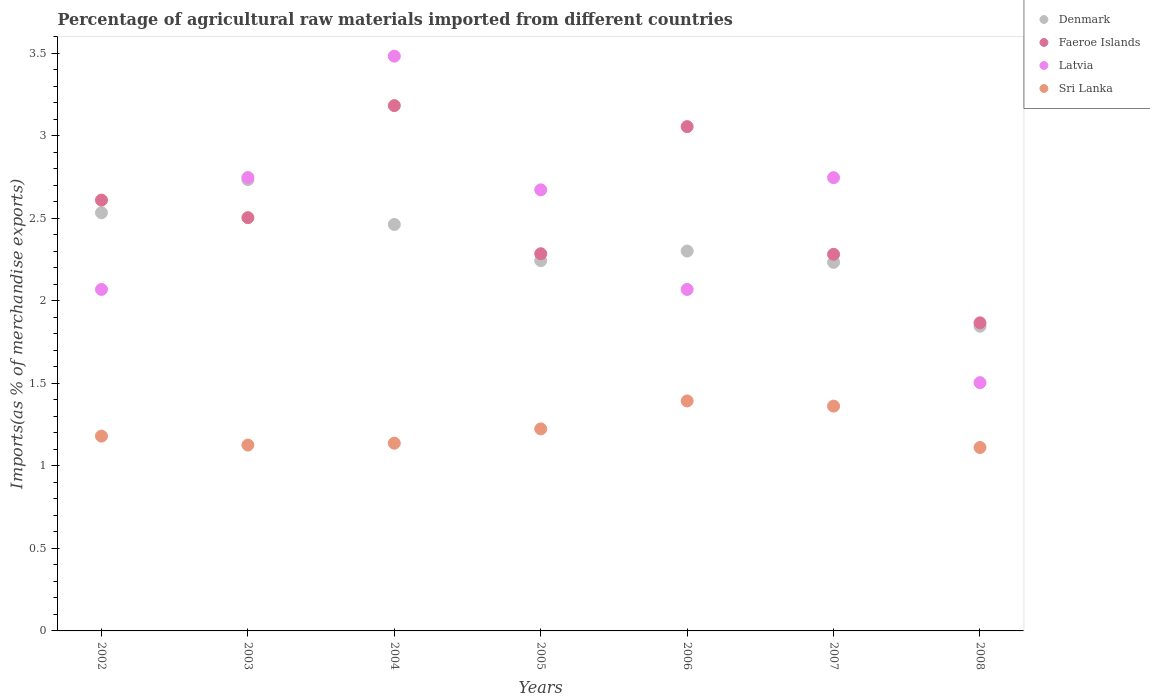Is the number of dotlines equal to the number of legend labels?
Give a very brief answer. Yes. What is the percentage of imports to different countries in Sri Lanka in 2003?
Your response must be concise. 1.13. Across all years, what is the maximum percentage of imports to different countries in Denmark?
Offer a very short reply. 2.73. Across all years, what is the minimum percentage of imports to different countries in Denmark?
Your answer should be very brief. 1.85. In which year was the percentage of imports to different countries in Faeroe Islands minimum?
Offer a terse response. 2008. What is the total percentage of imports to different countries in Latvia in the graph?
Provide a short and direct response. 17.29. What is the difference between the percentage of imports to different countries in Latvia in 2005 and that in 2008?
Your response must be concise. 1.17. What is the difference between the percentage of imports to different countries in Latvia in 2006 and the percentage of imports to different countries in Denmark in 2003?
Your answer should be compact. -0.67. What is the average percentage of imports to different countries in Latvia per year?
Your answer should be compact. 2.47. In the year 2002, what is the difference between the percentage of imports to different countries in Latvia and percentage of imports to different countries in Faeroe Islands?
Your answer should be very brief. -0.54. What is the ratio of the percentage of imports to different countries in Faeroe Islands in 2003 to that in 2005?
Keep it short and to the point. 1.1. Is the difference between the percentage of imports to different countries in Latvia in 2006 and 2007 greater than the difference between the percentage of imports to different countries in Faeroe Islands in 2006 and 2007?
Your answer should be compact. No. What is the difference between the highest and the second highest percentage of imports to different countries in Denmark?
Ensure brevity in your answer.  0.2. What is the difference between the highest and the lowest percentage of imports to different countries in Sri Lanka?
Provide a short and direct response. 0.28. Is it the case that in every year, the sum of the percentage of imports to different countries in Faeroe Islands and percentage of imports to different countries in Sri Lanka  is greater than the sum of percentage of imports to different countries in Latvia and percentage of imports to different countries in Denmark?
Provide a succinct answer. No. Is it the case that in every year, the sum of the percentage of imports to different countries in Sri Lanka and percentage of imports to different countries in Latvia  is greater than the percentage of imports to different countries in Denmark?
Your answer should be very brief. Yes. How many dotlines are there?
Your response must be concise. 4. How many years are there in the graph?
Your answer should be compact. 7. Are the values on the major ticks of Y-axis written in scientific E-notation?
Provide a short and direct response. No. What is the title of the graph?
Offer a terse response. Percentage of agricultural raw materials imported from different countries. Does "Austria" appear as one of the legend labels in the graph?
Make the answer very short. No. What is the label or title of the X-axis?
Offer a terse response. Years. What is the label or title of the Y-axis?
Offer a terse response. Imports(as % of merchandise exports). What is the Imports(as % of merchandise exports) in Denmark in 2002?
Provide a succinct answer. 2.53. What is the Imports(as % of merchandise exports) of Faeroe Islands in 2002?
Your answer should be very brief. 2.61. What is the Imports(as % of merchandise exports) in Latvia in 2002?
Your answer should be compact. 2.07. What is the Imports(as % of merchandise exports) in Sri Lanka in 2002?
Your answer should be very brief. 1.18. What is the Imports(as % of merchandise exports) in Denmark in 2003?
Provide a succinct answer. 2.73. What is the Imports(as % of merchandise exports) in Faeroe Islands in 2003?
Provide a succinct answer. 2.5. What is the Imports(as % of merchandise exports) of Latvia in 2003?
Your answer should be compact. 2.75. What is the Imports(as % of merchandise exports) of Sri Lanka in 2003?
Provide a succinct answer. 1.13. What is the Imports(as % of merchandise exports) in Denmark in 2004?
Your answer should be very brief. 2.46. What is the Imports(as % of merchandise exports) of Faeroe Islands in 2004?
Give a very brief answer. 3.18. What is the Imports(as % of merchandise exports) in Latvia in 2004?
Ensure brevity in your answer.  3.48. What is the Imports(as % of merchandise exports) of Sri Lanka in 2004?
Make the answer very short. 1.14. What is the Imports(as % of merchandise exports) in Denmark in 2005?
Ensure brevity in your answer.  2.24. What is the Imports(as % of merchandise exports) in Faeroe Islands in 2005?
Offer a terse response. 2.29. What is the Imports(as % of merchandise exports) of Latvia in 2005?
Your response must be concise. 2.67. What is the Imports(as % of merchandise exports) in Sri Lanka in 2005?
Offer a very short reply. 1.22. What is the Imports(as % of merchandise exports) in Denmark in 2006?
Provide a succinct answer. 2.3. What is the Imports(as % of merchandise exports) of Faeroe Islands in 2006?
Provide a succinct answer. 3.06. What is the Imports(as % of merchandise exports) of Latvia in 2006?
Ensure brevity in your answer.  2.07. What is the Imports(as % of merchandise exports) of Sri Lanka in 2006?
Your answer should be compact. 1.39. What is the Imports(as % of merchandise exports) of Denmark in 2007?
Make the answer very short. 2.23. What is the Imports(as % of merchandise exports) in Faeroe Islands in 2007?
Provide a short and direct response. 2.28. What is the Imports(as % of merchandise exports) of Latvia in 2007?
Make the answer very short. 2.75. What is the Imports(as % of merchandise exports) in Sri Lanka in 2007?
Provide a succinct answer. 1.36. What is the Imports(as % of merchandise exports) in Denmark in 2008?
Your answer should be very brief. 1.85. What is the Imports(as % of merchandise exports) of Faeroe Islands in 2008?
Make the answer very short. 1.87. What is the Imports(as % of merchandise exports) of Latvia in 2008?
Provide a succinct answer. 1.5. What is the Imports(as % of merchandise exports) of Sri Lanka in 2008?
Provide a succinct answer. 1.11. Across all years, what is the maximum Imports(as % of merchandise exports) of Denmark?
Offer a very short reply. 2.73. Across all years, what is the maximum Imports(as % of merchandise exports) in Faeroe Islands?
Your answer should be compact. 3.18. Across all years, what is the maximum Imports(as % of merchandise exports) of Latvia?
Ensure brevity in your answer.  3.48. Across all years, what is the maximum Imports(as % of merchandise exports) of Sri Lanka?
Give a very brief answer. 1.39. Across all years, what is the minimum Imports(as % of merchandise exports) in Denmark?
Offer a terse response. 1.85. Across all years, what is the minimum Imports(as % of merchandise exports) in Faeroe Islands?
Offer a terse response. 1.87. Across all years, what is the minimum Imports(as % of merchandise exports) in Latvia?
Offer a terse response. 1.5. Across all years, what is the minimum Imports(as % of merchandise exports) in Sri Lanka?
Make the answer very short. 1.11. What is the total Imports(as % of merchandise exports) of Denmark in the graph?
Make the answer very short. 16.35. What is the total Imports(as % of merchandise exports) in Faeroe Islands in the graph?
Give a very brief answer. 17.79. What is the total Imports(as % of merchandise exports) in Latvia in the graph?
Provide a succinct answer. 17.29. What is the total Imports(as % of merchandise exports) of Sri Lanka in the graph?
Give a very brief answer. 8.54. What is the difference between the Imports(as % of merchandise exports) of Denmark in 2002 and that in 2003?
Offer a terse response. -0.2. What is the difference between the Imports(as % of merchandise exports) in Faeroe Islands in 2002 and that in 2003?
Make the answer very short. 0.11. What is the difference between the Imports(as % of merchandise exports) in Latvia in 2002 and that in 2003?
Your answer should be very brief. -0.68. What is the difference between the Imports(as % of merchandise exports) in Sri Lanka in 2002 and that in 2003?
Keep it short and to the point. 0.05. What is the difference between the Imports(as % of merchandise exports) of Denmark in 2002 and that in 2004?
Give a very brief answer. 0.07. What is the difference between the Imports(as % of merchandise exports) in Faeroe Islands in 2002 and that in 2004?
Ensure brevity in your answer.  -0.57. What is the difference between the Imports(as % of merchandise exports) in Latvia in 2002 and that in 2004?
Your response must be concise. -1.41. What is the difference between the Imports(as % of merchandise exports) in Sri Lanka in 2002 and that in 2004?
Your response must be concise. 0.04. What is the difference between the Imports(as % of merchandise exports) in Denmark in 2002 and that in 2005?
Give a very brief answer. 0.29. What is the difference between the Imports(as % of merchandise exports) in Faeroe Islands in 2002 and that in 2005?
Offer a very short reply. 0.32. What is the difference between the Imports(as % of merchandise exports) of Latvia in 2002 and that in 2005?
Ensure brevity in your answer.  -0.6. What is the difference between the Imports(as % of merchandise exports) in Sri Lanka in 2002 and that in 2005?
Ensure brevity in your answer.  -0.04. What is the difference between the Imports(as % of merchandise exports) in Denmark in 2002 and that in 2006?
Offer a very short reply. 0.23. What is the difference between the Imports(as % of merchandise exports) of Faeroe Islands in 2002 and that in 2006?
Your answer should be very brief. -0.45. What is the difference between the Imports(as % of merchandise exports) in Latvia in 2002 and that in 2006?
Provide a succinct answer. -0. What is the difference between the Imports(as % of merchandise exports) in Sri Lanka in 2002 and that in 2006?
Your answer should be very brief. -0.21. What is the difference between the Imports(as % of merchandise exports) in Denmark in 2002 and that in 2007?
Offer a terse response. 0.3. What is the difference between the Imports(as % of merchandise exports) in Faeroe Islands in 2002 and that in 2007?
Give a very brief answer. 0.33. What is the difference between the Imports(as % of merchandise exports) in Latvia in 2002 and that in 2007?
Your answer should be very brief. -0.68. What is the difference between the Imports(as % of merchandise exports) in Sri Lanka in 2002 and that in 2007?
Ensure brevity in your answer.  -0.18. What is the difference between the Imports(as % of merchandise exports) in Denmark in 2002 and that in 2008?
Make the answer very short. 0.69. What is the difference between the Imports(as % of merchandise exports) in Faeroe Islands in 2002 and that in 2008?
Ensure brevity in your answer.  0.74. What is the difference between the Imports(as % of merchandise exports) of Latvia in 2002 and that in 2008?
Your answer should be very brief. 0.56. What is the difference between the Imports(as % of merchandise exports) of Sri Lanka in 2002 and that in 2008?
Provide a succinct answer. 0.07. What is the difference between the Imports(as % of merchandise exports) of Denmark in 2003 and that in 2004?
Make the answer very short. 0.27. What is the difference between the Imports(as % of merchandise exports) of Faeroe Islands in 2003 and that in 2004?
Ensure brevity in your answer.  -0.68. What is the difference between the Imports(as % of merchandise exports) of Latvia in 2003 and that in 2004?
Your response must be concise. -0.74. What is the difference between the Imports(as % of merchandise exports) in Sri Lanka in 2003 and that in 2004?
Offer a terse response. -0.01. What is the difference between the Imports(as % of merchandise exports) in Denmark in 2003 and that in 2005?
Give a very brief answer. 0.49. What is the difference between the Imports(as % of merchandise exports) of Faeroe Islands in 2003 and that in 2005?
Your response must be concise. 0.22. What is the difference between the Imports(as % of merchandise exports) of Latvia in 2003 and that in 2005?
Ensure brevity in your answer.  0.07. What is the difference between the Imports(as % of merchandise exports) in Sri Lanka in 2003 and that in 2005?
Ensure brevity in your answer.  -0.1. What is the difference between the Imports(as % of merchandise exports) in Denmark in 2003 and that in 2006?
Your answer should be very brief. 0.43. What is the difference between the Imports(as % of merchandise exports) in Faeroe Islands in 2003 and that in 2006?
Provide a short and direct response. -0.55. What is the difference between the Imports(as % of merchandise exports) in Latvia in 2003 and that in 2006?
Make the answer very short. 0.68. What is the difference between the Imports(as % of merchandise exports) in Sri Lanka in 2003 and that in 2006?
Make the answer very short. -0.27. What is the difference between the Imports(as % of merchandise exports) in Denmark in 2003 and that in 2007?
Offer a terse response. 0.5. What is the difference between the Imports(as % of merchandise exports) in Faeroe Islands in 2003 and that in 2007?
Your response must be concise. 0.22. What is the difference between the Imports(as % of merchandise exports) of Latvia in 2003 and that in 2007?
Your answer should be very brief. 0. What is the difference between the Imports(as % of merchandise exports) of Sri Lanka in 2003 and that in 2007?
Provide a succinct answer. -0.24. What is the difference between the Imports(as % of merchandise exports) in Denmark in 2003 and that in 2008?
Provide a short and direct response. 0.89. What is the difference between the Imports(as % of merchandise exports) of Faeroe Islands in 2003 and that in 2008?
Make the answer very short. 0.64. What is the difference between the Imports(as % of merchandise exports) of Latvia in 2003 and that in 2008?
Your response must be concise. 1.24. What is the difference between the Imports(as % of merchandise exports) of Sri Lanka in 2003 and that in 2008?
Provide a short and direct response. 0.01. What is the difference between the Imports(as % of merchandise exports) of Denmark in 2004 and that in 2005?
Offer a terse response. 0.22. What is the difference between the Imports(as % of merchandise exports) of Faeroe Islands in 2004 and that in 2005?
Offer a very short reply. 0.9. What is the difference between the Imports(as % of merchandise exports) of Latvia in 2004 and that in 2005?
Make the answer very short. 0.81. What is the difference between the Imports(as % of merchandise exports) in Sri Lanka in 2004 and that in 2005?
Offer a very short reply. -0.09. What is the difference between the Imports(as % of merchandise exports) in Denmark in 2004 and that in 2006?
Ensure brevity in your answer.  0.16. What is the difference between the Imports(as % of merchandise exports) in Faeroe Islands in 2004 and that in 2006?
Provide a succinct answer. 0.13. What is the difference between the Imports(as % of merchandise exports) in Latvia in 2004 and that in 2006?
Provide a succinct answer. 1.41. What is the difference between the Imports(as % of merchandise exports) of Sri Lanka in 2004 and that in 2006?
Offer a very short reply. -0.26. What is the difference between the Imports(as % of merchandise exports) in Denmark in 2004 and that in 2007?
Your response must be concise. 0.23. What is the difference between the Imports(as % of merchandise exports) of Faeroe Islands in 2004 and that in 2007?
Provide a short and direct response. 0.9. What is the difference between the Imports(as % of merchandise exports) of Latvia in 2004 and that in 2007?
Ensure brevity in your answer.  0.74. What is the difference between the Imports(as % of merchandise exports) in Sri Lanka in 2004 and that in 2007?
Offer a terse response. -0.22. What is the difference between the Imports(as % of merchandise exports) of Denmark in 2004 and that in 2008?
Ensure brevity in your answer.  0.62. What is the difference between the Imports(as % of merchandise exports) in Faeroe Islands in 2004 and that in 2008?
Provide a short and direct response. 1.32. What is the difference between the Imports(as % of merchandise exports) in Latvia in 2004 and that in 2008?
Provide a succinct answer. 1.98. What is the difference between the Imports(as % of merchandise exports) of Sri Lanka in 2004 and that in 2008?
Give a very brief answer. 0.03. What is the difference between the Imports(as % of merchandise exports) of Denmark in 2005 and that in 2006?
Provide a short and direct response. -0.06. What is the difference between the Imports(as % of merchandise exports) in Faeroe Islands in 2005 and that in 2006?
Provide a succinct answer. -0.77. What is the difference between the Imports(as % of merchandise exports) of Latvia in 2005 and that in 2006?
Provide a succinct answer. 0.6. What is the difference between the Imports(as % of merchandise exports) in Sri Lanka in 2005 and that in 2006?
Your response must be concise. -0.17. What is the difference between the Imports(as % of merchandise exports) of Denmark in 2005 and that in 2007?
Keep it short and to the point. 0.01. What is the difference between the Imports(as % of merchandise exports) in Faeroe Islands in 2005 and that in 2007?
Provide a short and direct response. 0. What is the difference between the Imports(as % of merchandise exports) of Latvia in 2005 and that in 2007?
Give a very brief answer. -0.07. What is the difference between the Imports(as % of merchandise exports) in Sri Lanka in 2005 and that in 2007?
Provide a short and direct response. -0.14. What is the difference between the Imports(as % of merchandise exports) of Denmark in 2005 and that in 2008?
Keep it short and to the point. 0.4. What is the difference between the Imports(as % of merchandise exports) of Faeroe Islands in 2005 and that in 2008?
Give a very brief answer. 0.42. What is the difference between the Imports(as % of merchandise exports) of Latvia in 2005 and that in 2008?
Offer a terse response. 1.17. What is the difference between the Imports(as % of merchandise exports) of Sri Lanka in 2005 and that in 2008?
Your response must be concise. 0.11. What is the difference between the Imports(as % of merchandise exports) in Denmark in 2006 and that in 2007?
Ensure brevity in your answer.  0.07. What is the difference between the Imports(as % of merchandise exports) of Faeroe Islands in 2006 and that in 2007?
Keep it short and to the point. 0.77. What is the difference between the Imports(as % of merchandise exports) of Latvia in 2006 and that in 2007?
Keep it short and to the point. -0.68. What is the difference between the Imports(as % of merchandise exports) of Sri Lanka in 2006 and that in 2007?
Your response must be concise. 0.03. What is the difference between the Imports(as % of merchandise exports) in Denmark in 2006 and that in 2008?
Your response must be concise. 0.46. What is the difference between the Imports(as % of merchandise exports) in Faeroe Islands in 2006 and that in 2008?
Give a very brief answer. 1.19. What is the difference between the Imports(as % of merchandise exports) of Latvia in 2006 and that in 2008?
Ensure brevity in your answer.  0.56. What is the difference between the Imports(as % of merchandise exports) of Sri Lanka in 2006 and that in 2008?
Your response must be concise. 0.28. What is the difference between the Imports(as % of merchandise exports) of Denmark in 2007 and that in 2008?
Your answer should be compact. 0.39. What is the difference between the Imports(as % of merchandise exports) of Faeroe Islands in 2007 and that in 2008?
Your answer should be very brief. 0.42. What is the difference between the Imports(as % of merchandise exports) of Latvia in 2007 and that in 2008?
Your answer should be compact. 1.24. What is the difference between the Imports(as % of merchandise exports) in Sri Lanka in 2007 and that in 2008?
Provide a short and direct response. 0.25. What is the difference between the Imports(as % of merchandise exports) of Denmark in 2002 and the Imports(as % of merchandise exports) of Faeroe Islands in 2003?
Your response must be concise. 0.03. What is the difference between the Imports(as % of merchandise exports) of Denmark in 2002 and the Imports(as % of merchandise exports) of Latvia in 2003?
Offer a terse response. -0.21. What is the difference between the Imports(as % of merchandise exports) in Denmark in 2002 and the Imports(as % of merchandise exports) in Sri Lanka in 2003?
Your answer should be very brief. 1.41. What is the difference between the Imports(as % of merchandise exports) of Faeroe Islands in 2002 and the Imports(as % of merchandise exports) of Latvia in 2003?
Keep it short and to the point. -0.14. What is the difference between the Imports(as % of merchandise exports) of Faeroe Islands in 2002 and the Imports(as % of merchandise exports) of Sri Lanka in 2003?
Offer a very short reply. 1.48. What is the difference between the Imports(as % of merchandise exports) in Latvia in 2002 and the Imports(as % of merchandise exports) in Sri Lanka in 2003?
Provide a short and direct response. 0.94. What is the difference between the Imports(as % of merchandise exports) of Denmark in 2002 and the Imports(as % of merchandise exports) of Faeroe Islands in 2004?
Offer a terse response. -0.65. What is the difference between the Imports(as % of merchandise exports) of Denmark in 2002 and the Imports(as % of merchandise exports) of Latvia in 2004?
Your response must be concise. -0.95. What is the difference between the Imports(as % of merchandise exports) of Denmark in 2002 and the Imports(as % of merchandise exports) of Sri Lanka in 2004?
Make the answer very short. 1.4. What is the difference between the Imports(as % of merchandise exports) of Faeroe Islands in 2002 and the Imports(as % of merchandise exports) of Latvia in 2004?
Offer a very short reply. -0.87. What is the difference between the Imports(as % of merchandise exports) in Faeroe Islands in 2002 and the Imports(as % of merchandise exports) in Sri Lanka in 2004?
Give a very brief answer. 1.47. What is the difference between the Imports(as % of merchandise exports) in Latvia in 2002 and the Imports(as % of merchandise exports) in Sri Lanka in 2004?
Your answer should be very brief. 0.93. What is the difference between the Imports(as % of merchandise exports) in Denmark in 2002 and the Imports(as % of merchandise exports) in Faeroe Islands in 2005?
Provide a succinct answer. 0.25. What is the difference between the Imports(as % of merchandise exports) in Denmark in 2002 and the Imports(as % of merchandise exports) in Latvia in 2005?
Provide a short and direct response. -0.14. What is the difference between the Imports(as % of merchandise exports) of Denmark in 2002 and the Imports(as % of merchandise exports) of Sri Lanka in 2005?
Provide a succinct answer. 1.31. What is the difference between the Imports(as % of merchandise exports) of Faeroe Islands in 2002 and the Imports(as % of merchandise exports) of Latvia in 2005?
Make the answer very short. -0.06. What is the difference between the Imports(as % of merchandise exports) in Faeroe Islands in 2002 and the Imports(as % of merchandise exports) in Sri Lanka in 2005?
Ensure brevity in your answer.  1.39. What is the difference between the Imports(as % of merchandise exports) of Latvia in 2002 and the Imports(as % of merchandise exports) of Sri Lanka in 2005?
Provide a short and direct response. 0.84. What is the difference between the Imports(as % of merchandise exports) in Denmark in 2002 and the Imports(as % of merchandise exports) in Faeroe Islands in 2006?
Your answer should be compact. -0.52. What is the difference between the Imports(as % of merchandise exports) of Denmark in 2002 and the Imports(as % of merchandise exports) of Latvia in 2006?
Make the answer very short. 0.46. What is the difference between the Imports(as % of merchandise exports) in Denmark in 2002 and the Imports(as % of merchandise exports) in Sri Lanka in 2006?
Offer a terse response. 1.14. What is the difference between the Imports(as % of merchandise exports) of Faeroe Islands in 2002 and the Imports(as % of merchandise exports) of Latvia in 2006?
Make the answer very short. 0.54. What is the difference between the Imports(as % of merchandise exports) in Faeroe Islands in 2002 and the Imports(as % of merchandise exports) in Sri Lanka in 2006?
Give a very brief answer. 1.22. What is the difference between the Imports(as % of merchandise exports) in Latvia in 2002 and the Imports(as % of merchandise exports) in Sri Lanka in 2006?
Provide a short and direct response. 0.68. What is the difference between the Imports(as % of merchandise exports) of Denmark in 2002 and the Imports(as % of merchandise exports) of Faeroe Islands in 2007?
Offer a terse response. 0.25. What is the difference between the Imports(as % of merchandise exports) of Denmark in 2002 and the Imports(as % of merchandise exports) of Latvia in 2007?
Your response must be concise. -0.21. What is the difference between the Imports(as % of merchandise exports) in Denmark in 2002 and the Imports(as % of merchandise exports) in Sri Lanka in 2007?
Keep it short and to the point. 1.17. What is the difference between the Imports(as % of merchandise exports) of Faeroe Islands in 2002 and the Imports(as % of merchandise exports) of Latvia in 2007?
Your answer should be very brief. -0.14. What is the difference between the Imports(as % of merchandise exports) of Faeroe Islands in 2002 and the Imports(as % of merchandise exports) of Sri Lanka in 2007?
Provide a succinct answer. 1.25. What is the difference between the Imports(as % of merchandise exports) in Latvia in 2002 and the Imports(as % of merchandise exports) in Sri Lanka in 2007?
Offer a very short reply. 0.71. What is the difference between the Imports(as % of merchandise exports) in Denmark in 2002 and the Imports(as % of merchandise exports) in Faeroe Islands in 2008?
Provide a short and direct response. 0.67. What is the difference between the Imports(as % of merchandise exports) of Denmark in 2002 and the Imports(as % of merchandise exports) of Latvia in 2008?
Your answer should be compact. 1.03. What is the difference between the Imports(as % of merchandise exports) of Denmark in 2002 and the Imports(as % of merchandise exports) of Sri Lanka in 2008?
Your response must be concise. 1.42. What is the difference between the Imports(as % of merchandise exports) in Faeroe Islands in 2002 and the Imports(as % of merchandise exports) in Latvia in 2008?
Make the answer very short. 1.11. What is the difference between the Imports(as % of merchandise exports) of Faeroe Islands in 2002 and the Imports(as % of merchandise exports) of Sri Lanka in 2008?
Ensure brevity in your answer.  1.5. What is the difference between the Imports(as % of merchandise exports) in Latvia in 2002 and the Imports(as % of merchandise exports) in Sri Lanka in 2008?
Offer a terse response. 0.96. What is the difference between the Imports(as % of merchandise exports) of Denmark in 2003 and the Imports(as % of merchandise exports) of Faeroe Islands in 2004?
Your answer should be compact. -0.45. What is the difference between the Imports(as % of merchandise exports) in Denmark in 2003 and the Imports(as % of merchandise exports) in Latvia in 2004?
Provide a succinct answer. -0.75. What is the difference between the Imports(as % of merchandise exports) in Denmark in 2003 and the Imports(as % of merchandise exports) in Sri Lanka in 2004?
Give a very brief answer. 1.6. What is the difference between the Imports(as % of merchandise exports) in Faeroe Islands in 2003 and the Imports(as % of merchandise exports) in Latvia in 2004?
Keep it short and to the point. -0.98. What is the difference between the Imports(as % of merchandise exports) of Faeroe Islands in 2003 and the Imports(as % of merchandise exports) of Sri Lanka in 2004?
Give a very brief answer. 1.37. What is the difference between the Imports(as % of merchandise exports) in Latvia in 2003 and the Imports(as % of merchandise exports) in Sri Lanka in 2004?
Provide a short and direct response. 1.61. What is the difference between the Imports(as % of merchandise exports) in Denmark in 2003 and the Imports(as % of merchandise exports) in Faeroe Islands in 2005?
Ensure brevity in your answer.  0.45. What is the difference between the Imports(as % of merchandise exports) in Denmark in 2003 and the Imports(as % of merchandise exports) in Latvia in 2005?
Give a very brief answer. 0.06. What is the difference between the Imports(as % of merchandise exports) in Denmark in 2003 and the Imports(as % of merchandise exports) in Sri Lanka in 2005?
Offer a terse response. 1.51. What is the difference between the Imports(as % of merchandise exports) in Faeroe Islands in 2003 and the Imports(as % of merchandise exports) in Latvia in 2005?
Your response must be concise. -0.17. What is the difference between the Imports(as % of merchandise exports) of Faeroe Islands in 2003 and the Imports(as % of merchandise exports) of Sri Lanka in 2005?
Offer a very short reply. 1.28. What is the difference between the Imports(as % of merchandise exports) of Latvia in 2003 and the Imports(as % of merchandise exports) of Sri Lanka in 2005?
Provide a short and direct response. 1.52. What is the difference between the Imports(as % of merchandise exports) in Denmark in 2003 and the Imports(as % of merchandise exports) in Faeroe Islands in 2006?
Offer a terse response. -0.32. What is the difference between the Imports(as % of merchandise exports) in Denmark in 2003 and the Imports(as % of merchandise exports) in Latvia in 2006?
Offer a terse response. 0.67. What is the difference between the Imports(as % of merchandise exports) in Denmark in 2003 and the Imports(as % of merchandise exports) in Sri Lanka in 2006?
Provide a succinct answer. 1.34. What is the difference between the Imports(as % of merchandise exports) in Faeroe Islands in 2003 and the Imports(as % of merchandise exports) in Latvia in 2006?
Your response must be concise. 0.43. What is the difference between the Imports(as % of merchandise exports) of Faeroe Islands in 2003 and the Imports(as % of merchandise exports) of Sri Lanka in 2006?
Keep it short and to the point. 1.11. What is the difference between the Imports(as % of merchandise exports) in Latvia in 2003 and the Imports(as % of merchandise exports) in Sri Lanka in 2006?
Your response must be concise. 1.35. What is the difference between the Imports(as % of merchandise exports) in Denmark in 2003 and the Imports(as % of merchandise exports) in Faeroe Islands in 2007?
Offer a very short reply. 0.45. What is the difference between the Imports(as % of merchandise exports) of Denmark in 2003 and the Imports(as % of merchandise exports) of Latvia in 2007?
Ensure brevity in your answer.  -0.01. What is the difference between the Imports(as % of merchandise exports) in Denmark in 2003 and the Imports(as % of merchandise exports) in Sri Lanka in 2007?
Provide a succinct answer. 1.37. What is the difference between the Imports(as % of merchandise exports) of Faeroe Islands in 2003 and the Imports(as % of merchandise exports) of Latvia in 2007?
Your answer should be very brief. -0.24. What is the difference between the Imports(as % of merchandise exports) of Faeroe Islands in 2003 and the Imports(as % of merchandise exports) of Sri Lanka in 2007?
Your answer should be compact. 1.14. What is the difference between the Imports(as % of merchandise exports) of Latvia in 2003 and the Imports(as % of merchandise exports) of Sri Lanka in 2007?
Offer a very short reply. 1.38. What is the difference between the Imports(as % of merchandise exports) of Denmark in 2003 and the Imports(as % of merchandise exports) of Faeroe Islands in 2008?
Your answer should be very brief. 0.87. What is the difference between the Imports(as % of merchandise exports) of Denmark in 2003 and the Imports(as % of merchandise exports) of Latvia in 2008?
Give a very brief answer. 1.23. What is the difference between the Imports(as % of merchandise exports) in Denmark in 2003 and the Imports(as % of merchandise exports) in Sri Lanka in 2008?
Offer a terse response. 1.62. What is the difference between the Imports(as % of merchandise exports) in Faeroe Islands in 2003 and the Imports(as % of merchandise exports) in Latvia in 2008?
Offer a very short reply. 1. What is the difference between the Imports(as % of merchandise exports) of Faeroe Islands in 2003 and the Imports(as % of merchandise exports) of Sri Lanka in 2008?
Provide a succinct answer. 1.39. What is the difference between the Imports(as % of merchandise exports) in Latvia in 2003 and the Imports(as % of merchandise exports) in Sri Lanka in 2008?
Your answer should be very brief. 1.64. What is the difference between the Imports(as % of merchandise exports) of Denmark in 2004 and the Imports(as % of merchandise exports) of Faeroe Islands in 2005?
Provide a short and direct response. 0.18. What is the difference between the Imports(as % of merchandise exports) of Denmark in 2004 and the Imports(as % of merchandise exports) of Latvia in 2005?
Your response must be concise. -0.21. What is the difference between the Imports(as % of merchandise exports) of Denmark in 2004 and the Imports(as % of merchandise exports) of Sri Lanka in 2005?
Keep it short and to the point. 1.24. What is the difference between the Imports(as % of merchandise exports) in Faeroe Islands in 2004 and the Imports(as % of merchandise exports) in Latvia in 2005?
Ensure brevity in your answer.  0.51. What is the difference between the Imports(as % of merchandise exports) in Faeroe Islands in 2004 and the Imports(as % of merchandise exports) in Sri Lanka in 2005?
Make the answer very short. 1.96. What is the difference between the Imports(as % of merchandise exports) in Latvia in 2004 and the Imports(as % of merchandise exports) in Sri Lanka in 2005?
Give a very brief answer. 2.26. What is the difference between the Imports(as % of merchandise exports) of Denmark in 2004 and the Imports(as % of merchandise exports) of Faeroe Islands in 2006?
Ensure brevity in your answer.  -0.59. What is the difference between the Imports(as % of merchandise exports) in Denmark in 2004 and the Imports(as % of merchandise exports) in Latvia in 2006?
Provide a succinct answer. 0.39. What is the difference between the Imports(as % of merchandise exports) in Denmark in 2004 and the Imports(as % of merchandise exports) in Sri Lanka in 2006?
Give a very brief answer. 1.07. What is the difference between the Imports(as % of merchandise exports) in Faeroe Islands in 2004 and the Imports(as % of merchandise exports) in Latvia in 2006?
Offer a terse response. 1.11. What is the difference between the Imports(as % of merchandise exports) of Faeroe Islands in 2004 and the Imports(as % of merchandise exports) of Sri Lanka in 2006?
Give a very brief answer. 1.79. What is the difference between the Imports(as % of merchandise exports) in Latvia in 2004 and the Imports(as % of merchandise exports) in Sri Lanka in 2006?
Your answer should be compact. 2.09. What is the difference between the Imports(as % of merchandise exports) in Denmark in 2004 and the Imports(as % of merchandise exports) in Faeroe Islands in 2007?
Provide a succinct answer. 0.18. What is the difference between the Imports(as % of merchandise exports) of Denmark in 2004 and the Imports(as % of merchandise exports) of Latvia in 2007?
Your response must be concise. -0.28. What is the difference between the Imports(as % of merchandise exports) in Denmark in 2004 and the Imports(as % of merchandise exports) in Sri Lanka in 2007?
Make the answer very short. 1.1. What is the difference between the Imports(as % of merchandise exports) of Faeroe Islands in 2004 and the Imports(as % of merchandise exports) of Latvia in 2007?
Provide a succinct answer. 0.44. What is the difference between the Imports(as % of merchandise exports) of Faeroe Islands in 2004 and the Imports(as % of merchandise exports) of Sri Lanka in 2007?
Offer a very short reply. 1.82. What is the difference between the Imports(as % of merchandise exports) in Latvia in 2004 and the Imports(as % of merchandise exports) in Sri Lanka in 2007?
Your response must be concise. 2.12. What is the difference between the Imports(as % of merchandise exports) of Denmark in 2004 and the Imports(as % of merchandise exports) of Faeroe Islands in 2008?
Offer a very short reply. 0.6. What is the difference between the Imports(as % of merchandise exports) of Denmark in 2004 and the Imports(as % of merchandise exports) of Latvia in 2008?
Provide a succinct answer. 0.96. What is the difference between the Imports(as % of merchandise exports) of Denmark in 2004 and the Imports(as % of merchandise exports) of Sri Lanka in 2008?
Offer a very short reply. 1.35. What is the difference between the Imports(as % of merchandise exports) of Faeroe Islands in 2004 and the Imports(as % of merchandise exports) of Latvia in 2008?
Your answer should be very brief. 1.68. What is the difference between the Imports(as % of merchandise exports) in Faeroe Islands in 2004 and the Imports(as % of merchandise exports) in Sri Lanka in 2008?
Your response must be concise. 2.07. What is the difference between the Imports(as % of merchandise exports) of Latvia in 2004 and the Imports(as % of merchandise exports) of Sri Lanka in 2008?
Make the answer very short. 2.37. What is the difference between the Imports(as % of merchandise exports) of Denmark in 2005 and the Imports(as % of merchandise exports) of Faeroe Islands in 2006?
Your answer should be very brief. -0.81. What is the difference between the Imports(as % of merchandise exports) of Denmark in 2005 and the Imports(as % of merchandise exports) of Latvia in 2006?
Your response must be concise. 0.17. What is the difference between the Imports(as % of merchandise exports) of Denmark in 2005 and the Imports(as % of merchandise exports) of Sri Lanka in 2006?
Your answer should be very brief. 0.85. What is the difference between the Imports(as % of merchandise exports) of Faeroe Islands in 2005 and the Imports(as % of merchandise exports) of Latvia in 2006?
Give a very brief answer. 0.22. What is the difference between the Imports(as % of merchandise exports) of Faeroe Islands in 2005 and the Imports(as % of merchandise exports) of Sri Lanka in 2006?
Your answer should be very brief. 0.89. What is the difference between the Imports(as % of merchandise exports) of Latvia in 2005 and the Imports(as % of merchandise exports) of Sri Lanka in 2006?
Your response must be concise. 1.28. What is the difference between the Imports(as % of merchandise exports) in Denmark in 2005 and the Imports(as % of merchandise exports) in Faeroe Islands in 2007?
Provide a short and direct response. -0.04. What is the difference between the Imports(as % of merchandise exports) in Denmark in 2005 and the Imports(as % of merchandise exports) in Latvia in 2007?
Give a very brief answer. -0.5. What is the difference between the Imports(as % of merchandise exports) in Denmark in 2005 and the Imports(as % of merchandise exports) in Sri Lanka in 2007?
Make the answer very short. 0.88. What is the difference between the Imports(as % of merchandise exports) of Faeroe Islands in 2005 and the Imports(as % of merchandise exports) of Latvia in 2007?
Provide a short and direct response. -0.46. What is the difference between the Imports(as % of merchandise exports) of Faeroe Islands in 2005 and the Imports(as % of merchandise exports) of Sri Lanka in 2007?
Your answer should be very brief. 0.92. What is the difference between the Imports(as % of merchandise exports) of Latvia in 2005 and the Imports(as % of merchandise exports) of Sri Lanka in 2007?
Provide a succinct answer. 1.31. What is the difference between the Imports(as % of merchandise exports) of Denmark in 2005 and the Imports(as % of merchandise exports) of Faeroe Islands in 2008?
Keep it short and to the point. 0.38. What is the difference between the Imports(as % of merchandise exports) in Denmark in 2005 and the Imports(as % of merchandise exports) in Latvia in 2008?
Make the answer very short. 0.74. What is the difference between the Imports(as % of merchandise exports) of Denmark in 2005 and the Imports(as % of merchandise exports) of Sri Lanka in 2008?
Your answer should be compact. 1.13. What is the difference between the Imports(as % of merchandise exports) of Faeroe Islands in 2005 and the Imports(as % of merchandise exports) of Latvia in 2008?
Your response must be concise. 0.78. What is the difference between the Imports(as % of merchandise exports) in Faeroe Islands in 2005 and the Imports(as % of merchandise exports) in Sri Lanka in 2008?
Your answer should be compact. 1.17. What is the difference between the Imports(as % of merchandise exports) of Latvia in 2005 and the Imports(as % of merchandise exports) of Sri Lanka in 2008?
Make the answer very short. 1.56. What is the difference between the Imports(as % of merchandise exports) in Denmark in 2006 and the Imports(as % of merchandise exports) in Faeroe Islands in 2007?
Your answer should be very brief. 0.02. What is the difference between the Imports(as % of merchandise exports) in Denmark in 2006 and the Imports(as % of merchandise exports) in Latvia in 2007?
Provide a succinct answer. -0.44. What is the difference between the Imports(as % of merchandise exports) in Denmark in 2006 and the Imports(as % of merchandise exports) in Sri Lanka in 2007?
Provide a short and direct response. 0.94. What is the difference between the Imports(as % of merchandise exports) in Faeroe Islands in 2006 and the Imports(as % of merchandise exports) in Latvia in 2007?
Keep it short and to the point. 0.31. What is the difference between the Imports(as % of merchandise exports) of Faeroe Islands in 2006 and the Imports(as % of merchandise exports) of Sri Lanka in 2007?
Ensure brevity in your answer.  1.69. What is the difference between the Imports(as % of merchandise exports) of Latvia in 2006 and the Imports(as % of merchandise exports) of Sri Lanka in 2007?
Provide a succinct answer. 0.71. What is the difference between the Imports(as % of merchandise exports) of Denmark in 2006 and the Imports(as % of merchandise exports) of Faeroe Islands in 2008?
Give a very brief answer. 0.43. What is the difference between the Imports(as % of merchandise exports) in Denmark in 2006 and the Imports(as % of merchandise exports) in Latvia in 2008?
Your response must be concise. 0.8. What is the difference between the Imports(as % of merchandise exports) in Denmark in 2006 and the Imports(as % of merchandise exports) in Sri Lanka in 2008?
Ensure brevity in your answer.  1.19. What is the difference between the Imports(as % of merchandise exports) of Faeroe Islands in 2006 and the Imports(as % of merchandise exports) of Latvia in 2008?
Your response must be concise. 1.55. What is the difference between the Imports(as % of merchandise exports) of Faeroe Islands in 2006 and the Imports(as % of merchandise exports) of Sri Lanka in 2008?
Your answer should be compact. 1.94. What is the difference between the Imports(as % of merchandise exports) in Latvia in 2006 and the Imports(as % of merchandise exports) in Sri Lanka in 2008?
Your answer should be compact. 0.96. What is the difference between the Imports(as % of merchandise exports) in Denmark in 2007 and the Imports(as % of merchandise exports) in Faeroe Islands in 2008?
Make the answer very short. 0.37. What is the difference between the Imports(as % of merchandise exports) in Denmark in 2007 and the Imports(as % of merchandise exports) in Latvia in 2008?
Keep it short and to the point. 0.73. What is the difference between the Imports(as % of merchandise exports) of Denmark in 2007 and the Imports(as % of merchandise exports) of Sri Lanka in 2008?
Make the answer very short. 1.12. What is the difference between the Imports(as % of merchandise exports) in Faeroe Islands in 2007 and the Imports(as % of merchandise exports) in Sri Lanka in 2008?
Offer a very short reply. 1.17. What is the difference between the Imports(as % of merchandise exports) in Latvia in 2007 and the Imports(as % of merchandise exports) in Sri Lanka in 2008?
Your answer should be very brief. 1.63. What is the average Imports(as % of merchandise exports) of Denmark per year?
Ensure brevity in your answer.  2.34. What is the average Imports(as % of merchandise exports) in Faeroe Islands per year?
Give a very brief answer. 2.54. What is the average Imports(as % of merchandise exports) in Latvia per year?
Your answer should be compact. 2.47. What is the average Imports(as % of merchandise exports) in Sri Lanka per year?
Your answer should be compact. 1.22. In the year 2002, what is the difference between the Imports(as % of merchandise exports) in Denmark and Imports(as % of merchandise exports) in Faeroe Islands?
Offer a terse response. -0.08. In the year 2002, what is the difference between the Imports(as % of merchandise exports) in Denmark and Imports(as % of merchandise exports) in Latvia?
Provide a short and direct response. 0.47. In the year 2002, what is the difference between the Imports(as % of merchandise exports) in Denmark and Imports(as % of merchandise exports) in Sri Lanka?
Your response must be concise. 1.35. In the year 2002, what is the difference between the Imports(as % of merchandise exports) in Faeroe Islands and Imports(as % of merchandise exports) in Latvia?
Offer a terse response. 0.54. In the year 2002, what is the difference between the Imports(as % of merchandise exports) in Faeroe Islands and Imports(as % of merchandise exports) in Sri Lanka?
Your answer should be compact. 1.43. In the year 2002, what is the difference between the Imports(as % of merchandise exports) in Latvia and Imports(as % of merchandise exports) in Sri Lanka?
Your answer should be very brief. 0.89. In the year 2003, what is the difference between the Imports(as % of merchandise exports) of Denmark and Imports(as % of merchandise exports) of Faeroe Islands?
Offer a terse response. 0.23. In the year 2003, what is the difference between the Imports(as % of merchandise exports) of Denmark and Imports(as % of merchandise exports) of Latvia?
Keep it short and to the point. -0.01. In the year 2003, what is the difference between the Imports(as % of merchandise exports) in Denmark and Imports(as % of merchandise exports) in Sri Lanka?
Provide a succinct answer. 1.61. In the year 2003, what is the difference between the Imports(as % of merchandise exports) of Faeroe Islands and Imports(as % of merchandise exports) of Latvia?
Ensure brevity in your answer.  -0.24. In the year 2003, what is the difference between the Imports(as % of merchandise exports) in Faeroe Islands and Imports(as % of merchandise exports) in Sri Lanka?
Provide a succinct answer. 1.38. In the year 2003, what is the difference between the Imports(as % of merchandise exports) in Latvia and Imports(as % of merchandise exports) in Sri Lanka?
Keep it short and to the point. 1.62. In the year 2004, what is the difference between the Imports(as % of merchandise exports) of Denmark and Imports(as % of merchandise exports) of Faeroe Islands?
Your answer should be compact. -0.72. In the year 2004, what is the difference between the Imports(as % of merchandise exports) of Denmark and Imports(as % of merchandise exports) of Latvia?
Your answer should be compact. -1.02. In the year 2004, what is the difference between the Imports(as % of merchandise exports) of Denmark and Imports(as % of merchandise exports) of Sri Lanka?
Your answer should be very brief. 1.33. In the year 2004, what is the difference between the Imports(as % of merchandise exports) of Faeroe Islands and Imports(as % of merchandise exports) of Latvia?
Your answer should be very brief. -0.3. In the year 2004, what is the difference between the Imports(as % of merchandise exports) of Faeroe Islands and Imports(as % of merchandise exports) of Sri Lanka?
Keep it short and to the point. 2.05. In the year 2004, what is the difference between the Imports(as % of merchandise exports) in Latvia and Imports(as % of merchandise exports) in Sri Lanka?
Give a very brief answer. 2.35. In the year 2005, what is the difference between the Imports(as % of merchandise exports) of Denmark and Imports(as % of merchandise exports) of Faeroe Islands?
Your answer should be compact. -0.04. In the year 2005, what is the difference between the Imports(as % of merchandise exports) of Denmark and Imports(as % of merchandise exports) of Latvia?
Make the answer very short. -0.43. In the year 2005, what is the difference between the Imports(as % of merchandise exports) in Denmark and Imports(as % of merchandise exports) in Sri Lanka?
Your answer should be compact. 1.02. In the year 2005, what is the difference between the Imports(as % of merchandise exports) in Faeroe Islands and Imports(as % of merchandise exports) in Latvia?
Your response must be concise. -0.39. In the year 2005, what is the difference between the Imports(as % of merchandise exports) in Faeroe Islands and Imports(as % of merchandise exports) in Sri Lanka?
Your answer should be very brief. 1.06. In the year 2005, what is the difference between the Imports(as % of merchandise exports) in Latvia and Imports(as % of merchandise exports) in Sri Lanka?
Give a very brief answer. 1.45. In the year 2006, what is the difference between the Imports(as % of merchandise exports) in Denmark and Imports(as % of merchandise exports) in Faeroe Islands?
Your answer should be compact. -0.75. In the year 2006, what is the difference between the Imports(as % of merchandise exports) of Denmark and Imports(as % of merchandise exports) of Latvia?
Your answer should be very brief. 0.23. In the year 2006, what is the difference between the Imports(as % of merchandise exports) of Denmark and Imports(as % of merchandise exports) of Sri Lanka?
Provide a short and direct response. 0.91. In the year 2006, what is the difference between the Imports(as % of merchandise exports) of Faeroe Islands and Imports(as % of merchandise exports) of Latvia?
Offer a terse response. 0.99. In the year 2006, what is the difference between the Imports(as % of merchandise exports) in Faeroe Islands and Imports(as % of merchandise exports) in Sri Lanka?
Provide a succinct answer. 1.66. In the year 2006, what is the difference between the Imports(as % of merchandise exports) of Latvia and Imports(as % of merchandise exports) of Sri Lanka?
Give a very brief answer. 0.68. In the year 2007, what is the difference between the Imports(as % of merchandise exports) in Denmark and Imports(as % of merchandise exports) in Faeroe Islands?
Give a very brief answer. -0.05. In the year 2007, what is the difference between the Imports(as % of merchandise exports) of Denmark and Imports(as % of merchandise exports) of Latvia?
Your response must be concise. -0.51. In the year 2007, what is the difference between the Imports(as % of merchandise exports) of Denmark and Imports(as % of merchandise exports) of Sri Lanka?
Your response must be concise. 0.87. In the year 2007, what is the difference between the Imports(as % of merchandise exports) of Faeroe Islands and Imports(as % of merchandise exports) of Latvia?
Provide a short and direct response. -0.46. In the year 2007, what is the difference between the Imports(as % of merchandise exports) in Faeroe Islands and Imports(as % of merchandise exports) in Sri Lanka?
Ensure brevity in your answer.  0.92. In the year 2007, what is the difference between the Imports(as % of merchandise exports) of Latvia and Imports(as % of merchandise exports) of Sri Lanka?
Offer a terse response. 1.38. In the year 2008, what is the difference between the Imports(as % of merchandise exports) in Denmark and Imports(as % of merchandise exports) in Faeroe Islands?
Your response must be concise. -0.02. In the year 2008, what is the difference between the Imports(as % of merchandise exports) of Denmark and Imports(as % of merchandise exports) of Latvia?
Your answer should be compact. 0.34. In the year 2008, what is the difference between the Imports(as % of merchandise exports) of Denmark and Imports(as % of merchandise exports) of Sri Lanka?
Ensure brevity in your answer.  0.73. In the year 2008, what is the difference between the Imports(as % of merchandise exports) in Faeroe Islands and Imports(as % of merchandise exports) in Latvia?
Make the answer very short. 0.36. In the year 2008, what is the difference between the Imports(as % of merchandise exports) of Faeroe Islands and Imports(as % of merchandise exports) of Sri Lanka?
Offer a terse response. 0.76. In the year 2008, what is the difference between the Imports(as % of merchandise exports) of Latvia and Imports(as % of merchandise exports) of Sri Lanka?
Offer a very short reply. 0.39. What is the ratio of the Imports(as % of merchandise exports) of Denmark in 2002 to that in 2003?
Your answer should be compact. 0.93. What is the ratio of the Imports(as % of merchandise exports) of Faeroe Islands in 2002 to that in 2003?
Provide a short and direct response. 1.04. What is the ratio of the Imports(as % of merchandise exports) of Latvia in 2002 to that in 2003?
Offer a very short reply. 0.75. What is the ratio of the Imports(as % of merchandise exports) in Sri Lanka in 2002 to that in 2003?
Your answer should be very brief. 1.05. What is the ratio of the Imports(as % of merchandise exports) in Denmark in 2002 to that in 2004?
Ensure brevity in your answer.  1.03. What is the ratio of the Imports(as % of merchandise exports) of Faeroe Islands in 2002 to that in 2004?
Provide a succinct answer. 0.82. What is the ratio of the Imports(as % of merchandise exports) in Latvia in 2002 to that in 2004?
Make the answer very short. 0.59. What is the ratio of the Imports(as % of merchandise exports) of Sri Lanka in 2002 to that in 2004?
Your answer should be very brief. 1.04. What is the ratio of the Imports(as % of merchandise exports) of Denmark in 2002 to that in 2005?
Give a very brief answer. 1.13. What is the ratio of the Imports(as % of merchandise exports) of Faeroe Islands in 2002 to that in 2005?
Your answer should be very brief. 1.14. What is the ratio of the Imports(as % of merchandise exports) in Latvia in 2002 to that in 2005?
Your response must be concise. 0.77. What is the ratio of the Imports(as % of merchandise exports) of Sri Lanka in 2002 to that in 2005?
Make the answer very short. 0.96. What is the ratio of the Imports(as % of merchandise exports) of Denmark in 2002 to that in 2006?
Keep it short and to the point. 1.1. What is the ratio of the Imports(as % of merchandise exports) in Faeroe Islands in 2002 to that in 2006?
Give a very brief answer. 0.85. What is the ratio of the Imports(as % of merchandise exports) of Latvia in 2002 to that in 2006?
Offer a terse response. 1. What is the ratio of the Imports(as % of merchandise exports) of Sri Lanka in 2002 to that in 2006?
Your answer should be very brief. 0.85. What is the ratio of the Imports(as % of merchandise exports) of Denmark in 2002 to that in 2007?
Offer a very short reply. 1.13. What is the ratio of the Imports(as % of merchandise exports) of Faeroe Islands in 2002 to that in 2007?
Offer a very short reply. 1.14. What is the ratio of the Imports(as % of merchandise exports) in Latvia in 2002 to that in 2007?
Offer a terse response. 0.75. What is the ratio of the Imports(as % of merchandise exports) of Sri Lanka in 2002 to that in 2007?
Your answer should be compact. 0.87. What is the ratio of the Imports(as % of merchandise exports) of Denmark in 2002 to that in 2008?
Your answer should be very brief. 1.37. What is the ratio of the Imports(as % of merchandise exports) in Faeroe Islands in 2002 to that in 2008?
Give a very brief answer. 1.4. What is the ratio of the Imports(as % of merchandise exports) in Latvia in 2002 to that in 2008?
Keep it short and to the point. 1.38. What is the ratio of the Imports(as % of merchandise exports) of Sri Lanka in 2002 to that in 2008?
Offer a terse response. 1.06. What is the ratio of the Imports(as % of merchandise exports) in Denmark in 2003 to that in 2004?
Ensure brevity in your answer.  1.11. What is the ratio of the Imports(as % of merchandise exports) of Faeroe Islands in 2003 to that in 2004?
Keep it short and to the point. 0.79. What is the ratio of the Imports(as % of merchandise exports) in Latvia in 2003 to that in 2004?
Your response must be concise. 0.79. What is the ratio of the Imports(as % of merchandise exports) of Sri Lanka in 2003 to that in 2004?
Give a very brief answer. 0.99. What is the ratio of the Imports(as % of merchandise exports) in Denmark in 2003 to that in 2005?
Make the answer very short. 1.22. What is the ratio of the Imports(as % of merchandise exports) of Faeroe Islands in 2003 to that in 2005?
Your response must be concise. 1.1. What is the ratio of the Imports(as % of merchandise exports) in Latvia in 2003 to that in 2005?
Offer a terse response. 1.03. What is the ratio of the Imports(as % of merchandise exports) of Sri Lanka in 2003 to that in 2005?
Provide a succinct answer. 0.92. What is the ratio of the Imports(as % of merchandise exports) in Denmark in 2003 to that in 2006?
Make the answer very short. 1.19. What is the ratio of the Imports(as % of merchandise exports) in Faeroe Islands in 2003 to that in 2006?
Ensure brevity in your answer.  0.82. What is the ratio of the Imports(as % of merchandise exports) in Latvia in 2003 to that in 2006?
Keep it short and to the point. 1.33. What is the ratio of the Imports(as % of merchandise exports) of Sri Lanka in 2003 to that in 2006?
Ensure brevity in your answer.  0.81. What is the ratio of the Imports(as % of merchandise exports) in Denmark in 2003 to that in 2007?
Provide a succinct answer. 1.22. What is the ratio of the Imports(as % of merchandise exports) in Faeroe Islands in 2003 to that in 2007?
Provide a succinct answer. 1.1. What is the ratio of the Imports(as % of merchandise exports) of Sri Lanka in 2003 to that in 2007?
Your answer should be compact. 0.83. What is the ratio of the Imports(as % of merchandise exports) of Denmark in 2003 to that in 2008?
Your answer should be very brief. 1.48. What is the ratio of the Imports(as % of merchandise exports) in Faeroe Islands in 2003 to that in 2008?
Provide a short and direct response. 1.34. What is the ratio of the Imports(as % of merchandise exports) in Latvia in 2003 to that in 2008?
Your response must be concise. 1.83. What is the ratio of the Imports(as % of merchandise exports) of Sri Lanka in 2003 to that in 2008?
Your response must be concise. 1.01. What is the ratio of the Imports(as % of merchandise exports) in Denmark in 2004 to that in 2005?
Your answer should be very brief. 1.1. What is the ratio of the Imports(as % of merchandise exports) of Faeroe Islands in 2004 to that in 2005?
Your answer should be very brief. 1.39. What is the ratio of the Imports(as % of merchandise exports) in Latvia in 2004 to that in 2005?
Provide a succinct answer. 1.3. What is the ratio of the Imports(as % of merchandise exports) in Sri Lanka in 2004 to that in 2005?
Keep it short and to the point. 0.93. What is the ratio of the Imports(as % of merchandise exports) in Denmark in 2004 to that in 2006?
Your response must be concise. 1.07. What is the ratio of the Imports(as % of merchandise exports) of Faeroe Islands in 2004 to that in 2006?
Ensure brevity in your answer.  1.04. What is the ratio of the Imports(as % of merchandise exports) of Latvia in 2004 to that in 2006?
Provide a succinct answer. 1.68. What is the ratio of the Imports(as % of merchandise exports) in Sri Lanka in 2004 to that in 2006?
Your answer should be compact. 0.82. What is the ratio of the Imports(as % of merchandise exports) in Denmark in 2004 to that in 2007?
Make the answer very short. 1.1. What is the ratio of the Imports(as % of merchandise exports) in Faeroe Islands in 2004 to that in 2007?
Your answer should be compact. 1.39. What is the ratio of the Imports(as % of merchandise exports) of Latvia in 2004 to that in 2007?
Give a very brief answer. 1.27. What is the ratio of the Imports(as % of merchandise exports) in Sri Lanka in 2004 to that in 2007?
Provide a short and direct response. 0.84. What is the ratio of the Imports(as % of merchandise exports) of Denmark in 2004 to that in 2008?
Your answer should be very brief. 1.33. What is the ratio of the Imports(as % of merchandise exports) of Faeroe Islands in 2004 to that in 2008?
Offer a terse response. 1.71. What is the ratio of the Imports(as % of merchandise exports) of Latvia in 2004 to that in 2008?
Provide a succinct answer. 2.32. What is the ratio of the Imports(as % of merchandise exports) of Sri Lanka in 2004 to that in 2008?
Offer a terse response. 1.02. What is the ratio of the Imports(as % of merchandise exports) in Denmark in 2005 to that in 2006?
Give a very brief answer. 0.97. What is the ratio of the Imports(as % of merchandise exports) of Faeroe Islands in 2005 to that in 2006?
Provide a succinct answer. 0.75. What is the ratio of the Imports(as % of merchandise exports) of Latvia in 2005 to that in 2006?
Your answer should be very brief. 1.29. What is the ratio of the Imports(as % of merchandise exports) of Sri Lanka in 2005 to that in 2006?
Provide a short and direct response. 0.88. What is the ratio of the Imports(as % of merchandise exports) in Faeroe Islands in 2005 to that in 2007?
Your answer should be compact. 1. What is the ratio of the Imports(as % of merchandise exports) in Latvia in 2005 to that in 2007?
Your answer should be compact. 0.97. What is the ratio of the Imports(as % of merchandise exports) of Sri Lanka in 2005 to that in 2007?
Offer a very short reply. 0.9. What is the ratio of the Imports(as % of merchandise exports) in Denmark in 2005 to that in 2008?
Ensure brevity in your answer.  1.22. What is the ratio of the Imports(as % of merchandise exports) in Faeroe Islands in 2005 to that in 2008?
Provide a succinct answer. 1.22. What is the ratio of the Imports(as % of merchandise exports) in Latvia in 2005 to that in 2008?
Offer a very short reply. 1.78. What is the ratio of the Imports(as % of merchandise exports) in Sri Lanka in 2005 to that in 2008?
Ensure brevity in your answer.  1.1. What is the ratio of the Imports(as % of merchandise exports) of Denmark in 2006 to that in 2007?
Your answer should be compact. 1.03. What is the ratio of the Imports(as % of merchandise exports) of Faeroe Islands in 2006 to that in 2007?
Offer a very short reply. 1.34. What is the ratio of the Imports(as % of merchandise exports) of Latvia in 2006 to that in 2007?
Offer a terse response. 0.75. What is the ratio of the Imports(as % of merchandise exports) of Sri Lanka in 2006 to that in 2007?
Your answer should be very brief. 1.02. What is the ratio of the Imports(as % of merchandise exports) of Denmark in 2006 to that in 2008?
Keep it short and to the point. 1.25. What is the ratio of the Imports(as % of merchandise exports) in Faeroe Islands in 2006 to that in 2008?
Ensure brevity in your answer.  1.64. What is the ratio of the Imports(as % of merchandise exports) in Latvia in 2006 to that in 2008?
Keep it short and to the point. 1.38. What is the ratio of the Imports(as % of merchandise exports) of Sri Lanka in 2006 to that in 2008?
Your answer should be very brief. 1.25. What is the ratio of the Imports(as % of merchandise exports) in Denmark in 2007 to that in 2008?
Your response must be concise. 1.21. What is the ratio of the Imports(as % of merchandise exports) in Faeroe Islands in 2007 to that in 2008?
Your answer should be compact. 1.22. What is the ratio of the Imports(as % of merchandise exports) in Latvia in 2007 to that in 2008?
Offer a terse response. 1.83. What is the ratio of the Imports(as % of merchandise exports) of Sri Lanka in 2007 to that in 2008?
Your response must be concise. 1.23. What is the difference between the highest and the second highest Imports(as % of merchandise exports) of Denmark?
Offer a very short reply. 0.2. What is the difference between the highest and the second highest Imports(as % of merchandise exports) of Faeroe Islands?
Provide a short and direct response. 0.13. What is the difference between the highest and the second highest Imports(as % of merchandise exports) of Latvia?
Offer a very short reply. 0.74. What is the difference between the highest and the second highest Imports(as % of merchandise exports) in Sri Lanka?
Ensure brevity in your answer.  0.03. What is the difference between the highest and the lowest Imports(as % of merchandise exports) in Denmark?
Offer a very short reply. 0.89. What is the difference between the highest and the lowest Imports(as % of merchandise exports) of Faeroe Islands?
Provide a short and direct response. 1.32. What is the difference between the highest and the lowest Imports(as % of merchandise exports) in Latvia?
Your answer should be very brief. 1.98. What is the difference between the highest and the lowest Imports(as % of merchandise exports) of Sri Lanka?
Make the answer very short. 0.28. 